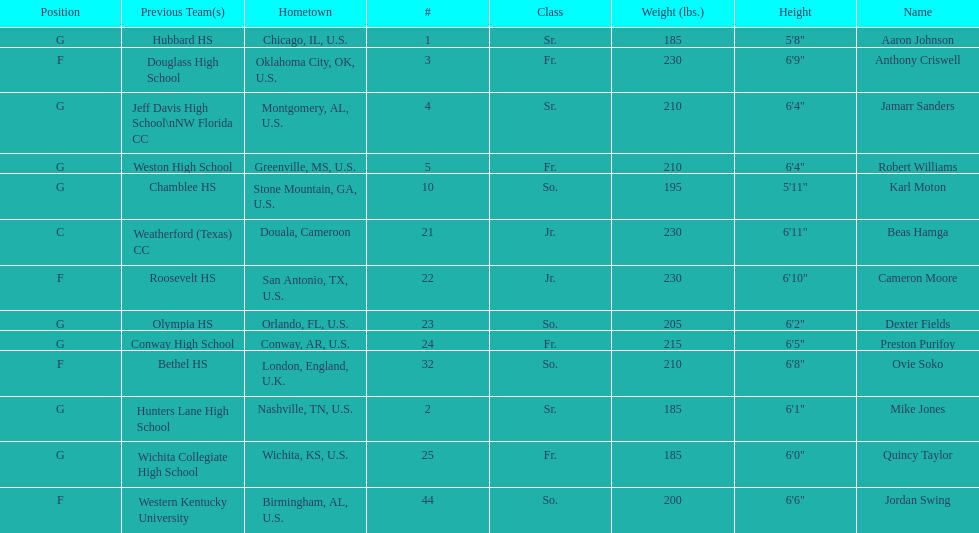Who weighs more, dexter fields or ovie soko? Ovie Soko. 